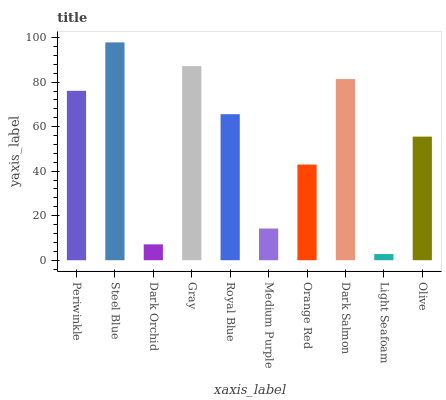Is Light Seafoam the minimum?
Answer yes or no. Yes. Is Steel Blue the maximum?
Answer yes or no. Yes. Is Dark Orchid the minimum?
Answer yes or no. No. Is Dark Orchid the maximum?
Answer yes or no. No. Is Steel Blue greater than Dark Orchid?
Answer yes or no. Yes. Is Dark Orchid less than Steel Blue?
Answer yes or no. Yes. Is Dark Orchid greater than Steel Blue?
Answer yes or no. No. Is Steel Blue less than Dark Orchid?
Answer yes or no. No. Is Royal Blue the high median?
Answer yes or no. Yes. Is Olive the low median?
Answer yes or no. Yes. Is Orange Red the high median?
Answer yes or no. No. Is Periwinkle the low median?
Answer yes or no. No. 